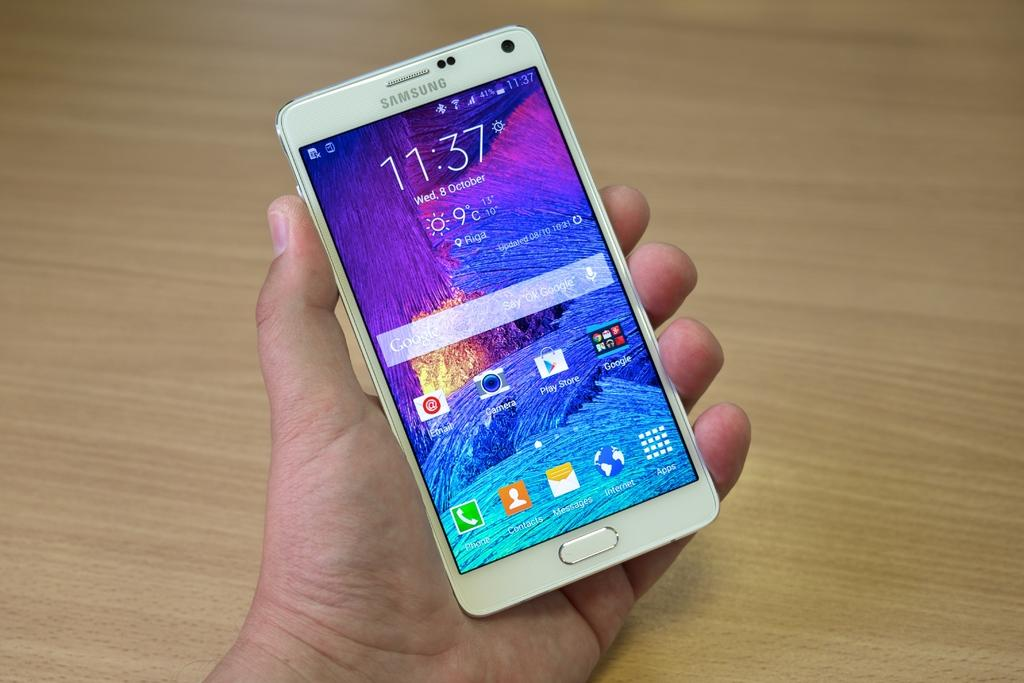Provide a one-sentence caption for the provided image. Samsung cell phone with the time of 11:37 in white on the front. 